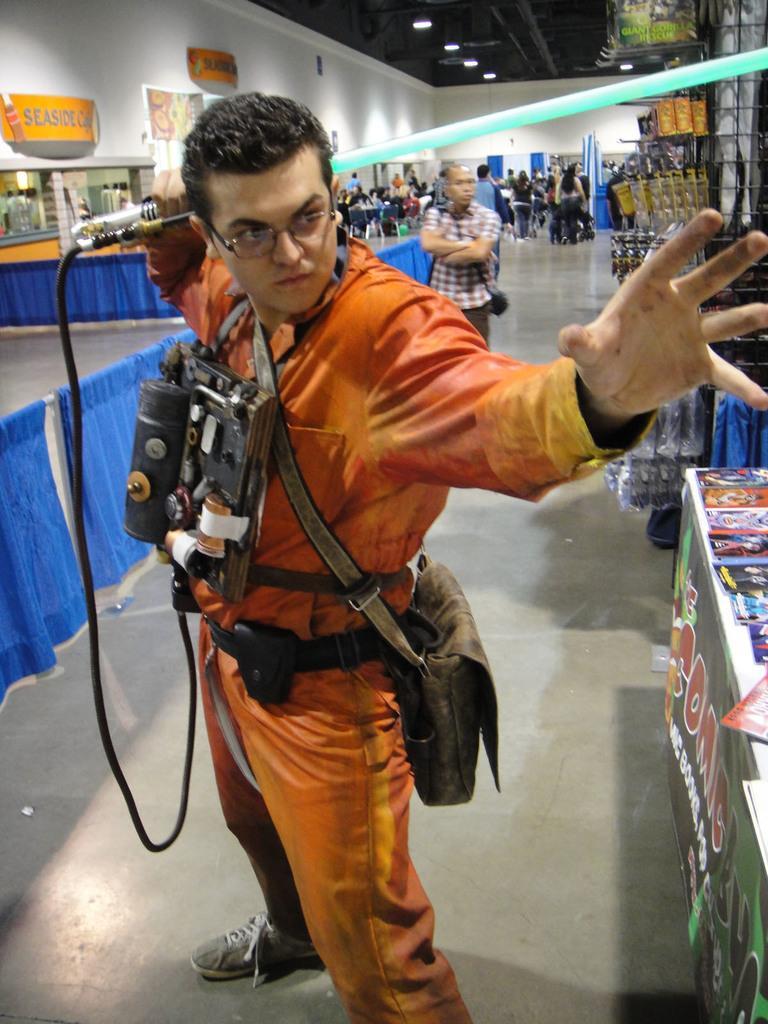How would you summarize this image in a sentence or two? In the middle of the image a person is standing and holding something in his hand. Behind him few people are standing, walking and we can see some tables, on the tables we can see some books and products. At the top of the image we can see wall, roof and lights, on the wall we can see some banners. 